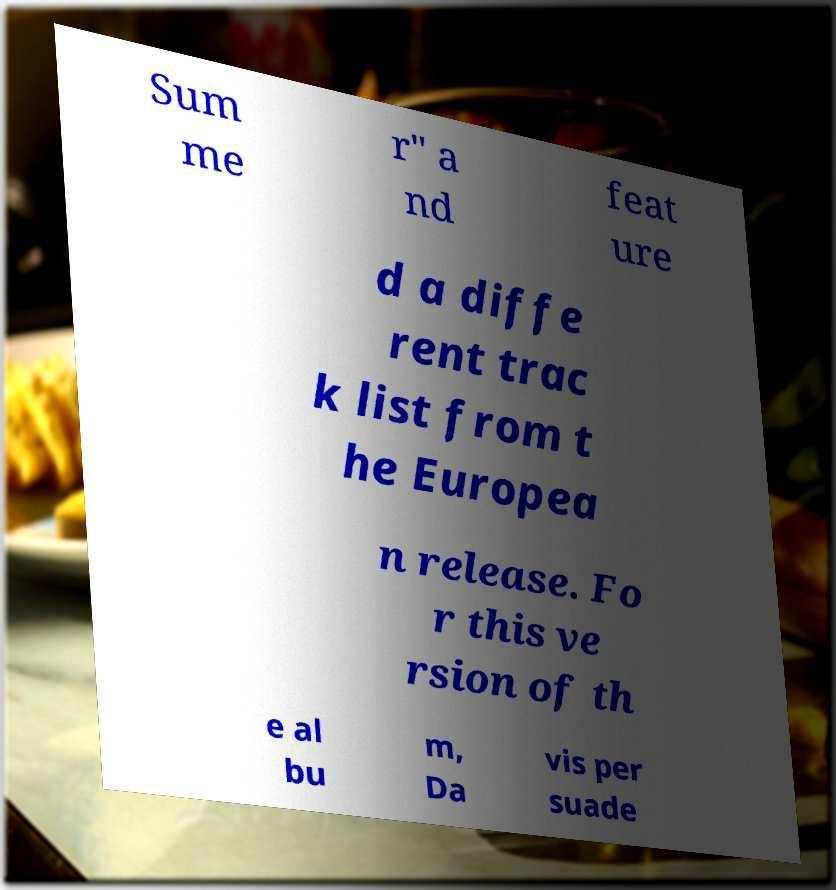I need the written content from this picture converted into text. Can you do that? Sum me r" a nd feat ure d a diffe rent trac k list from t he Europea n release. Fo r this ve rsion of th e al bu m, Da vis per suade 